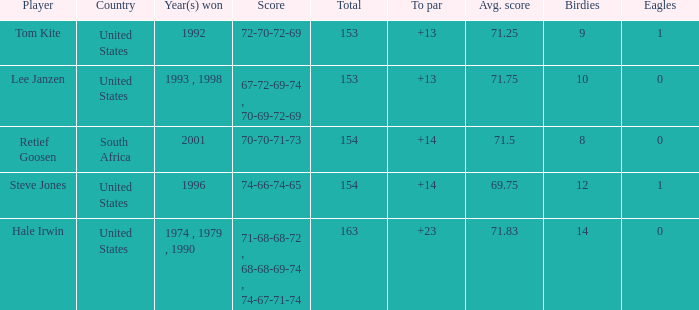What is the total that South Africa had a par greater than 14 None. 